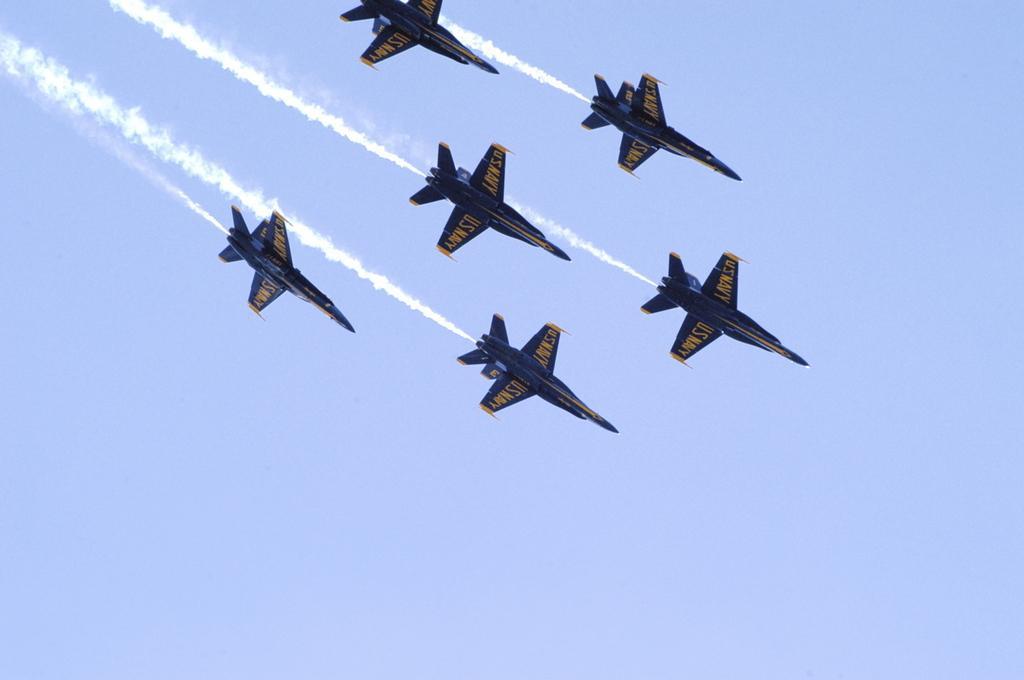In one or two sentences, can you explain what this image depicts? In this image I can see few aircraft's which are blue and yellow in color are flying in the air. I can see smoke behind them. In the background I can see the sky. 